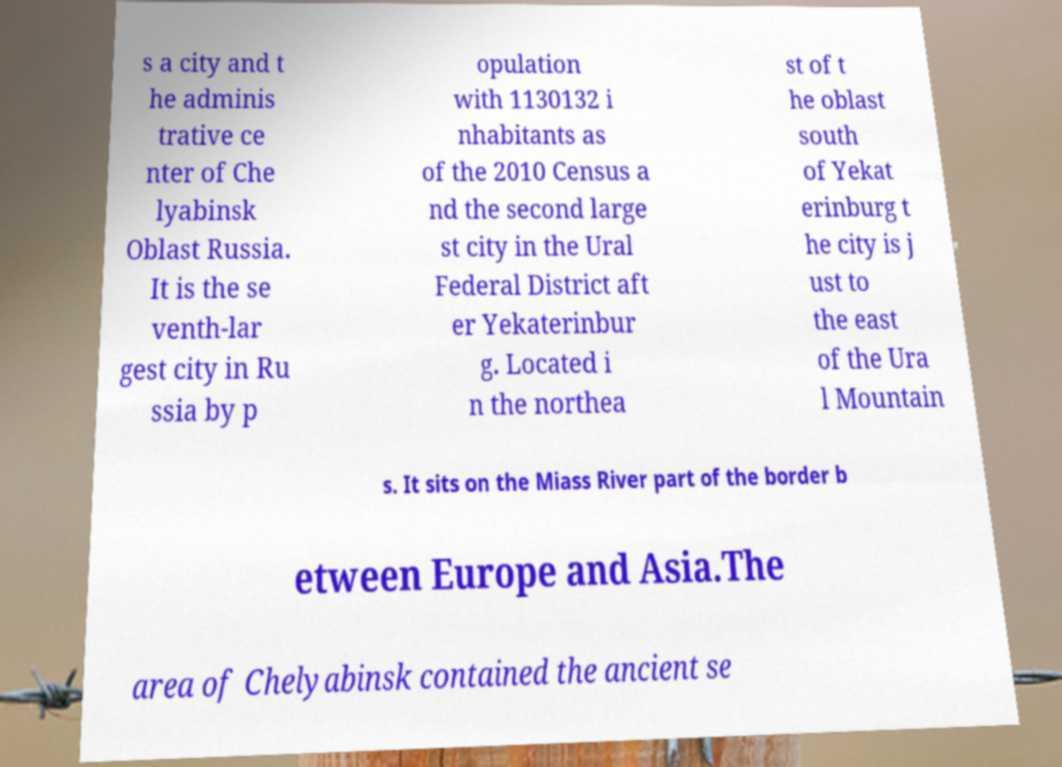What messages or text are displayed in this image? I need them in a readable, typed format. s a city and t he adminis trative ce nter of Che lyabinsk Oblast Russia. It is the se venth-lar gest city in Ru ssia by p opulation with 1130132 i nhabitants as of the 2010 Census a nd the second large st city in the Ural Federal District aft er Yekaterinbur g. Located i n the northea st of t he oblast south of Yekat erinburg t he city is j ust to the east of the Ura l Mountain s. It sits on the Miass River part of the border b etween Europe and Asia.The area of Chelyabinsk contained the ancient se 